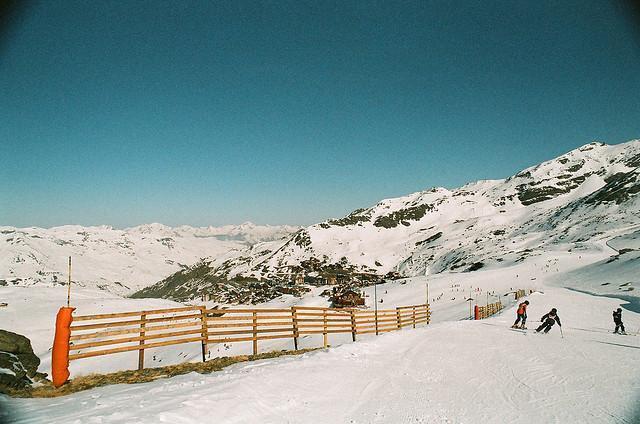How many train cars are orange?
Give a very brief answer. 0. 